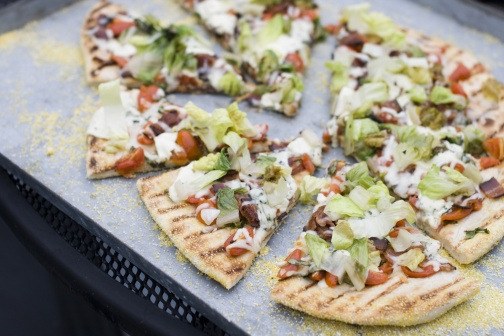Suppose this pizza was part of an art exhibition. What title and description would you give it? Title: 'Symphony of Freshness'
Description: This culinary masterpiece captures the essence of farm-fresh ingredients harmoniously assembled on a canvas of crispy crust. The vibrant hues of green lettuce, red tomatoes, and golden melted cheese contrast against the stark black tray, creating a visually striking composition. Each ingredient is meticulously placed, reflecting a symphony of flavors and textures that tell a story of nature's bounty. The rustic setting, with its coarse gray backdrop, adds to the narrative of simplicity and purity, celebrating the art of fresh, wholesome food prepared with love. 